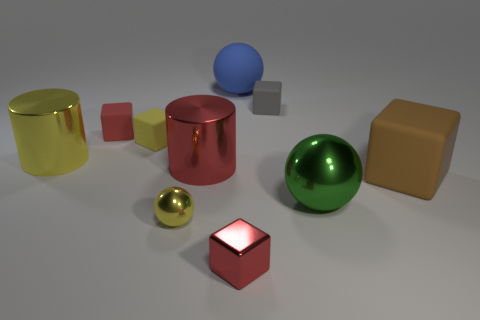Subtract all gray rubber blocks. How many blocks are left? 4 Subtract all brown blocks. How many blocks are left? 4 Subtract all cylinders. How many objects are left? 8 Subtract 3 blocks. How many blocks are left? 2 Add 7 tiny gray objects. How many tiny gray objects are left? 8 Add 5 large yellow shiny cylinders. How many large yellow shiny cylinders exist? 6 Subtract 0 green cylinders. How many objects are left? 10 Subtract all yellow blocks. Subtract all yellow spheres. How many blocks are left? 4 Subtract all blue cylinders. How many green spheres are left? 1 Subtract all gray matte objects. Subtract all brown matte things. How many objects are left? 8 